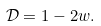Convert formula to latex. <formula><loc_0><loc_0><loc_500><loc_500>\mathcal { D } = 1 - 2 w .</formula> 